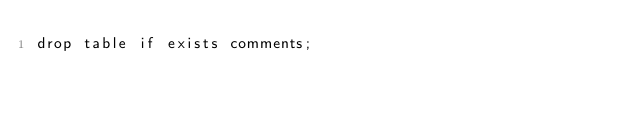<code> <loc_0><loc_0><loc_500><loc_500><_SQL_>drop table if exists comments;</code> 